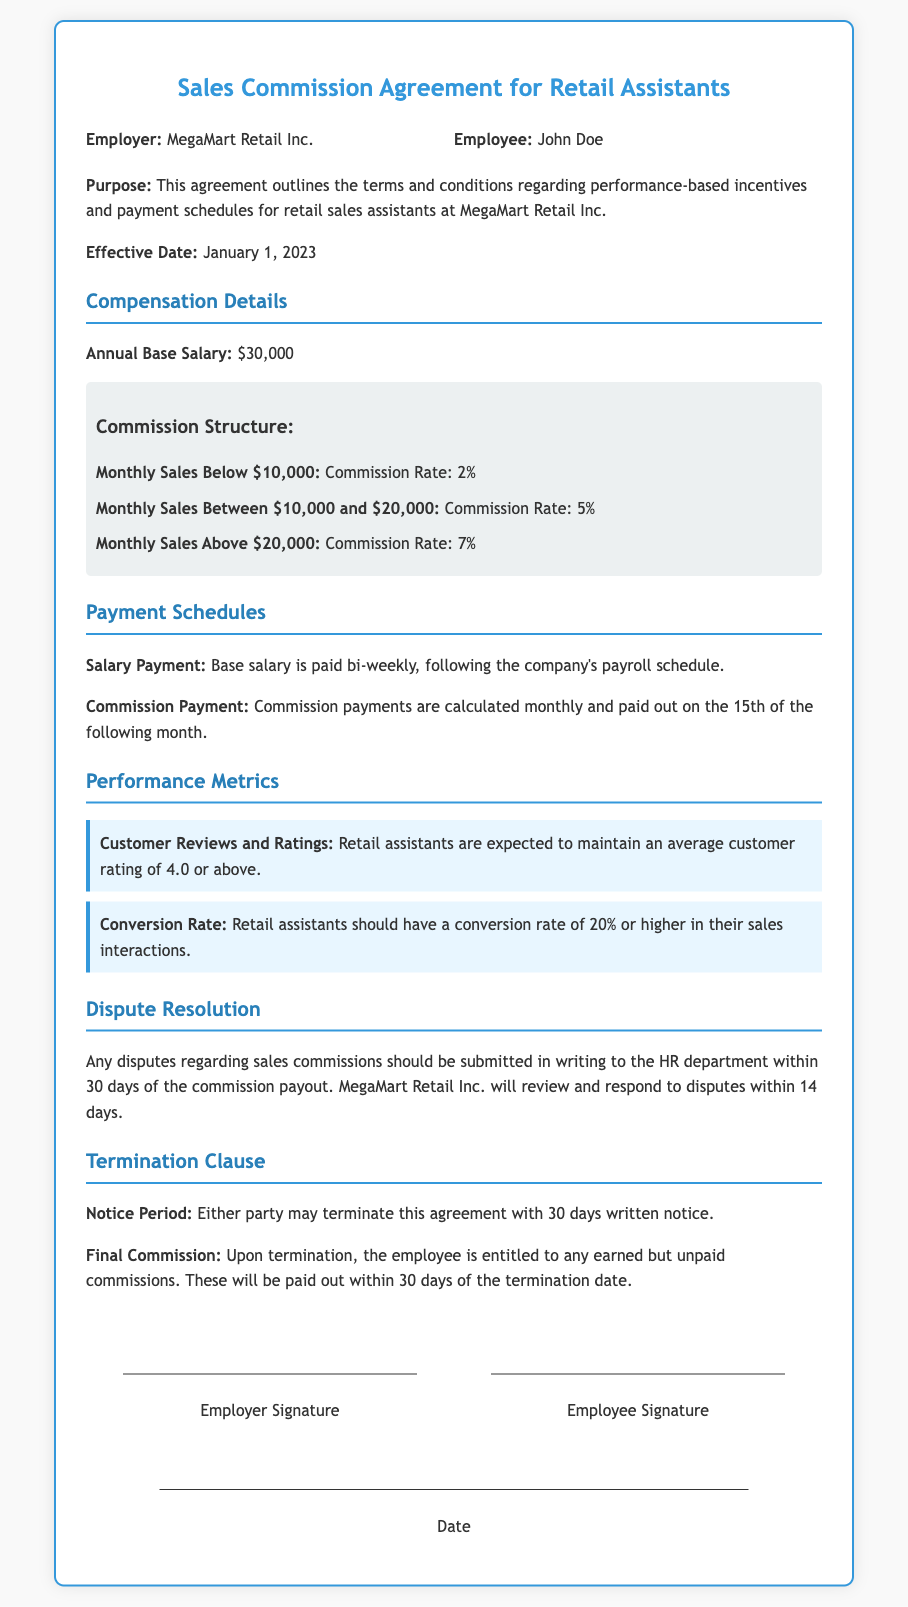What is the name of the employer? The employer is specified in the document as MegaMart Retail Inc.
Answer: MegaMart Retail Inc What is the effective date of the agreement? The document states that the effective date of the agreement is January 1, 2023.
Answer: January 1, 2023 What is the base salary mentioned in the contract? The annual base salary for the employee is included in the compensation details section as $30,000.
Answer: $30,000 What is the commission rate for sales above $20,000? The document specifies a commission rate of 7% for monthly sales above $20,000.
Answer: 7% What is the payment schedule for commission payments? The commission payment schedule indicates that commissions are paid out on the 15th of the following month.
Answer: 15th of the following month What is the required average customer rating for retail assistants? The document states that retail assistants are expected to maintain an average customer rating of 4.0 or above.
Answer: 4.0 How many days notice is required to terminate the agreement? The termination clause specifies that either party may terminate the agreement with 30 days written notice.
Answer: 30 days What is the minimum conversion rate expected from retail assistants? The document states that retail assistants should have a conversion rate of 20% or higher.
Answer: 20% What should you do if you have a dispute regarding sales commissions? The document instructs to submit disputes in writing to the HR department within 30 days of the commission payout.
Answer: Submit in writing to HR within 30 days 